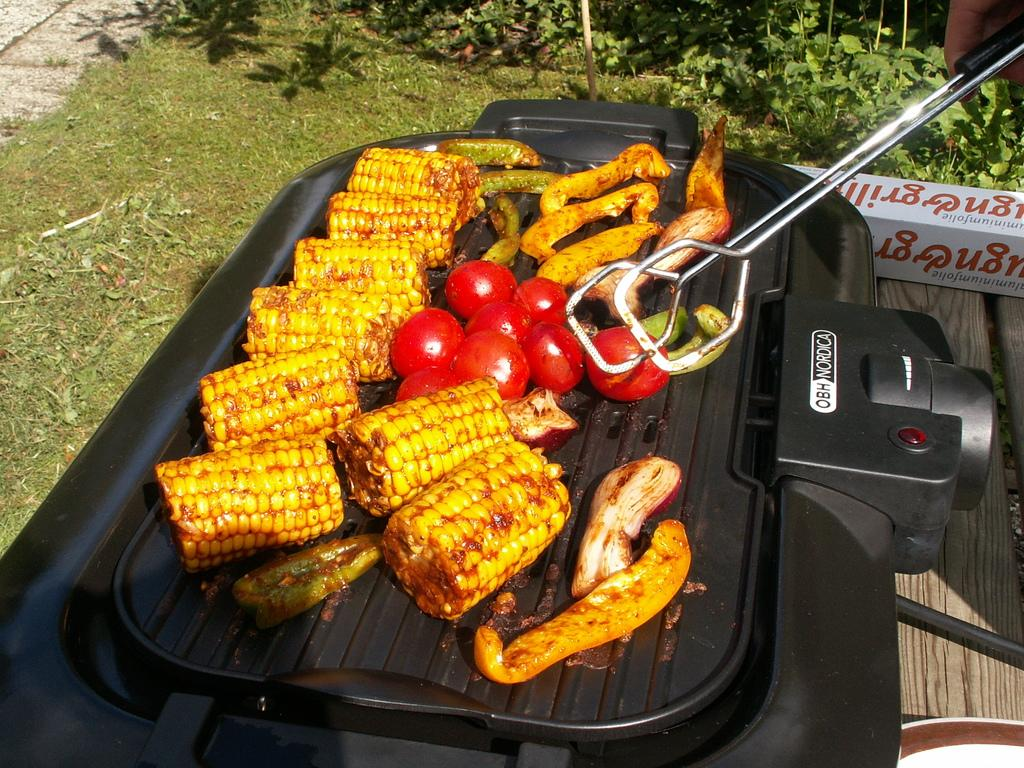<image>
Describe the image concisely. Someone cooks food on a OBH Nordica grill outside. 